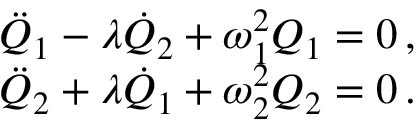<formula> <loc_0><loc_0><loc_500><loc_500>\begin{array} { r } { \ D d o t { Q } _ { 1 } - \lambda \dot { Q } _ { 2 } + \omega _ { 1 } ^ { 2 } Q _ { 1 } = 0 \, , } \\ { \ D d o t { Q } _ { 2 } + \lambda \dot { Q } _ { 1 } + \omega _ { 2 } ^ { 2 } Q _ { 2 } = 0 \, . } \end{array}</formula> 